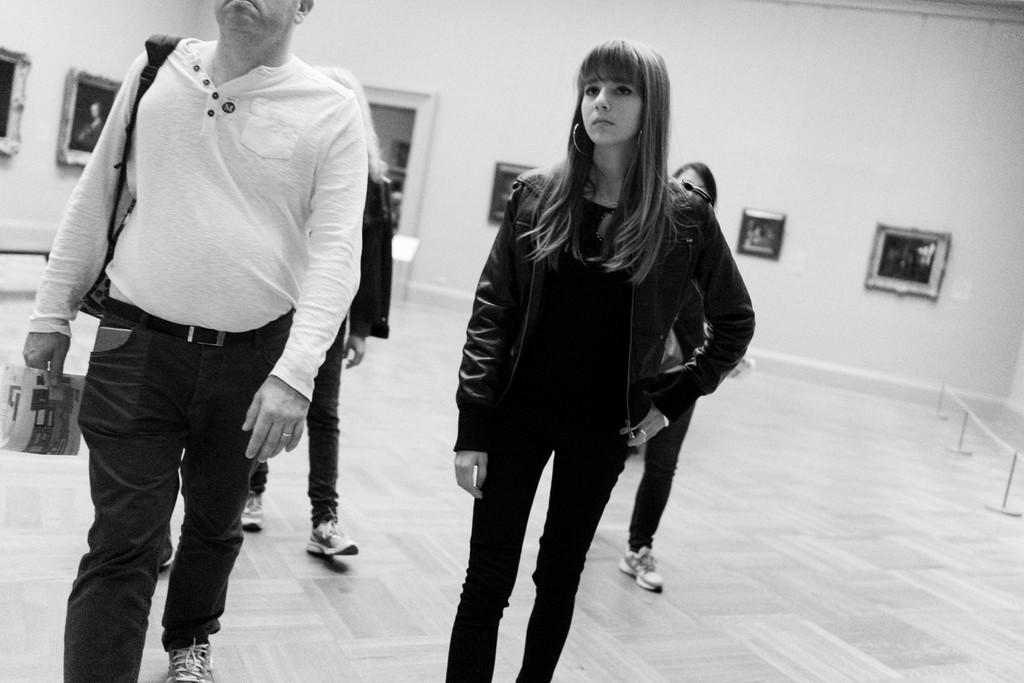How many people are present in the image? A: There are four people in the image. What are two of the people doing in the image? Two people are walking on the floor. What can be seen in the background of the image? There is a wall in the background of the image. What is on the wall in the image? The wall has photo frames on it. What type of degree can be seen hanging on the wall in the image? There is no degree visible in the image; only photo frames are mentioned on the wall. 